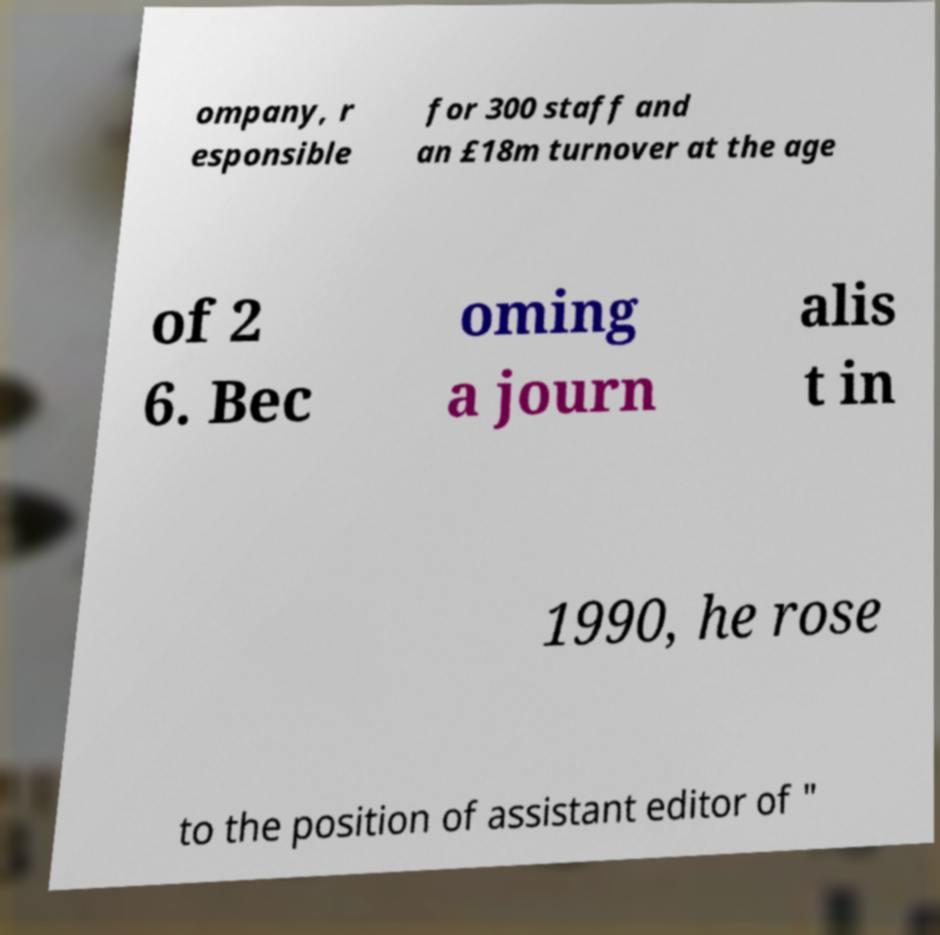Please read and relay the text visible in this image. What does it say? ompany, r esponsible for 300 staff and an £18m turnover at the age of 2 6. Bec oming a journ alis t in 1990, he rose to the position of assistant editor of " 